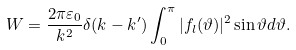<formula> <loc_0><loc_0><loc_500><loc_500>W = \frac { 2 \pi \varepsilon _ { 0 } } { k ^ { 2 } } \delta ( k - k ^ { \prime } ) \int _ { 0 } ^ { \pi } | f _ { l } ( \vartheta ) | ^ { 2 } \sin \vartheta d \vartheta .</formula> 